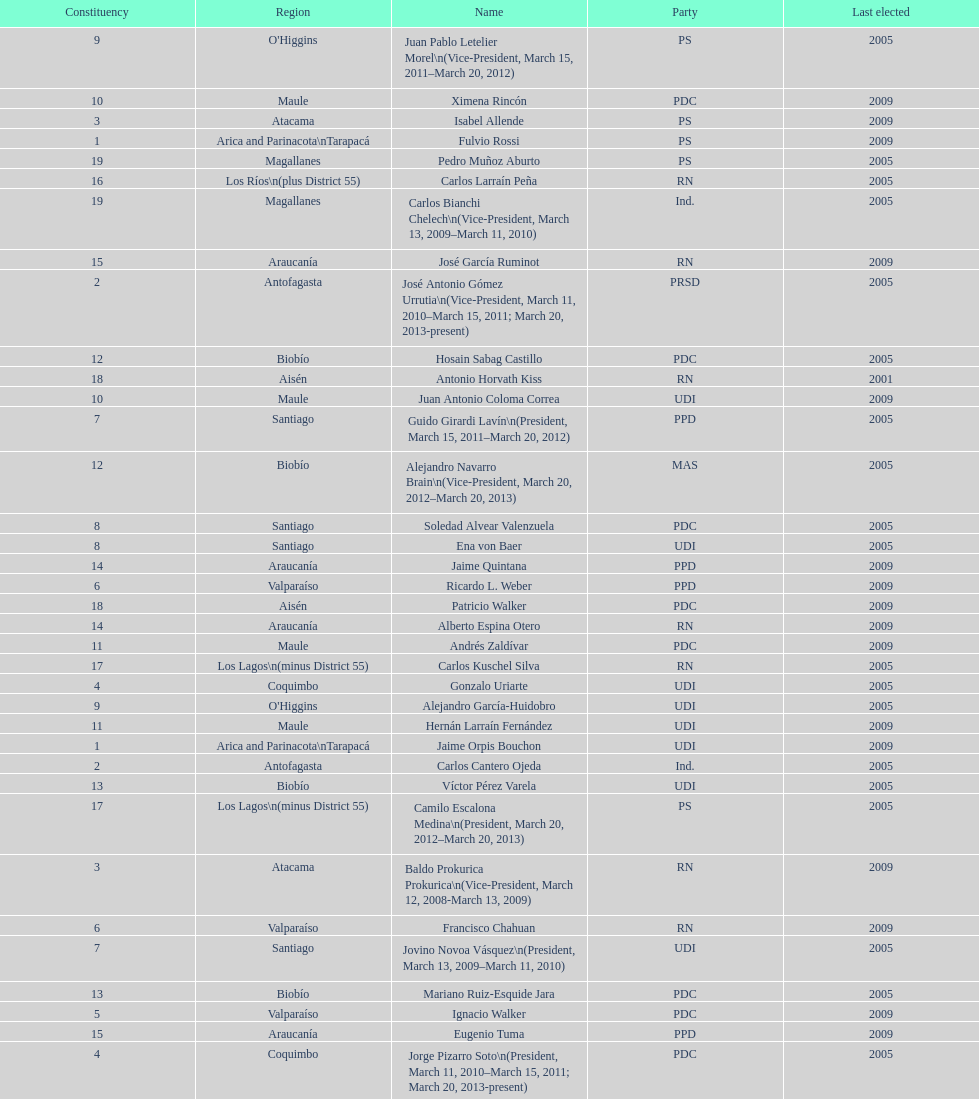What is the first name on the table? Fulvio Rossi. 